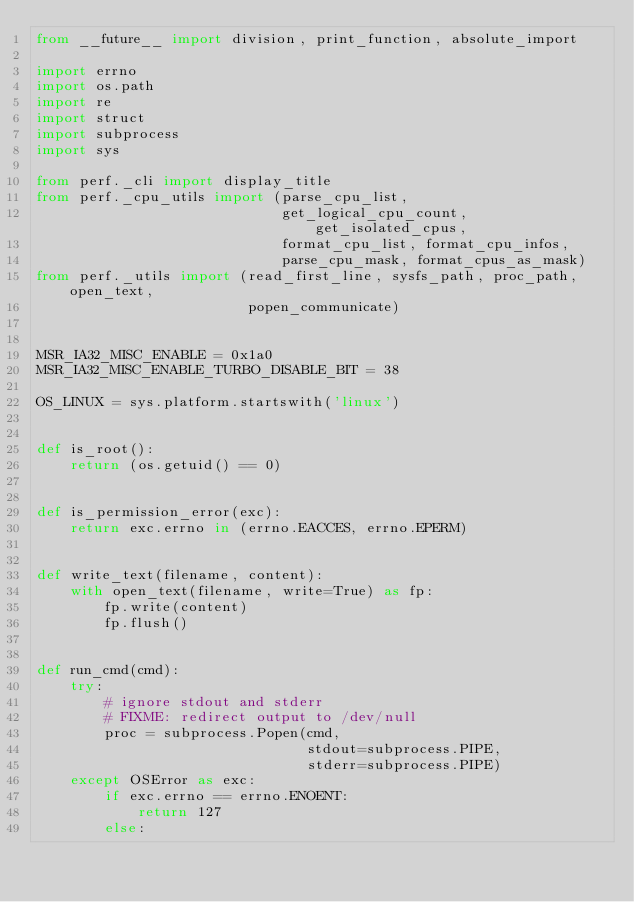Convert code to text. <code><loc_0><loc_0><loc_500><loc_500><_Python_>from __future__ import division, print_function, absolute_import

import errno
import os.path
import re
import struct
import subprocess
import sys

from perf._cli import display_title
from perf._cpu_utils import (parse_cpu_list,
                             get_logical_cpu_count, get_isolated_cpus,
                             format_cpu_list, format_cpu_infos,
                             parse_cpu_mask, format_cpus_as_mask)
from perf._utils import (read_first_line, sysfs_path, proc_path, open_text,
                         popen_communicate)


MSR_IA32_MISC_ENABLE = 0x1a0
MSR_IA32_MISC_ENABLE_TURBO_DISABLE_BIT = 38

OS_LINUX = sys.platform.startswith('linux')


def is_root():
    return (os.getuid() == 0)


def is_permission_error(exc):
    return exc.errno in (errno.EACCES, errno.EPERM)


def write_text(filename, content):
    with open_text(filename, write=True) as fp:
        fp.write(content)
        fp.flush()


def run_cmd(cmd):
    try:
        # ignore stdout and stderr
        # FIXME: redirect output to /dev/null
        proc = subprocess.Popen(cmd,
                                stdout=subprocess.PIPE,
                                stderr=subprocess.PIPE)
    except OSError as exc:
        if exc.errno == errno.ENOENT:
            return 127
        else:</code> 